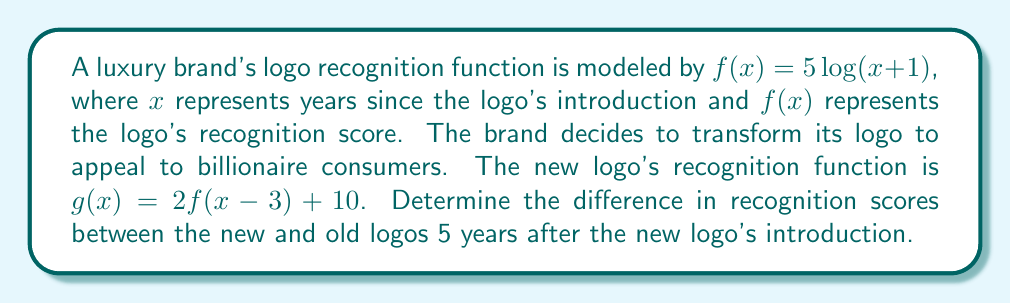Provide a solution to this math problem. To solve this problem, we need to follow these steps:

1) First, let's understand what the transformation does:
   $g(x) = 2f(x-3) + 10$ means:
   - Shift 3 units right: $(x-3)$
   - Stretch vertically by a factor of 2: $2f(x-3)$
   - Shift 10 units up: $+10$

2) Now, we need to calculate $g(5)$ and $f(5)$:

   For $g(5)$:
   $$\begin{align}
   g(5) &= 2f(5-3) + 10 \\
        &= 2f(2) + 10 \\
        &= 2(5\log(2+1)) + 10 \\
        &= 2(5\log(3)) + 10 \\
        &= 10\log(3) + 10
   \end{align}$$

   For $f(5)$:
   $$\begin{align}
   f(5) &= 5\log(5+1) \\
        &= 5\log(6)
   \end{align}$$

3) The difference in recognition scores is $g(5) - f(5)$:
   $$\begin{align}
   g(5) - f(5) &= (10\log(3) + 10) - 5\log(6) \\
               &= 10\log(3) + 10 - 5\log(6) \\
               &= 10\log(3) + 10 - 5(\log(2) + \log(3)) \\
               &= 10\log(3) + 10 - 5\log(2) - 5\log(3) \\
               &= 5\log(3) + 10 - 5\log(2)
   \end{align}$$

This expression represents the difference in recognition scores 5 years after the new logo's introduction.
Answer: $5\log(3) + 10 - 5\log(2)$ 